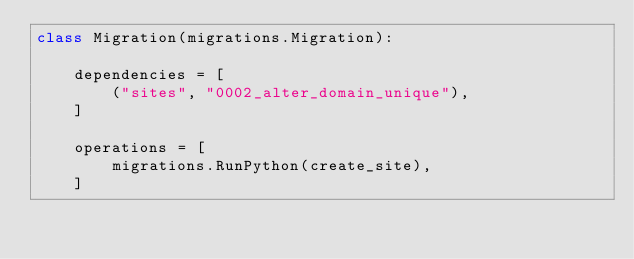Convert code to text. <code><loc_0><loc_0><loc_500><loc_500><_Python_>class Migration(migrations.Migration):

    dependencies = [
        ("sites", "0002_alter_domain_unique"),
    ]

    operations = [
        migrations.RunPython(create_site),
    ]
</code> 